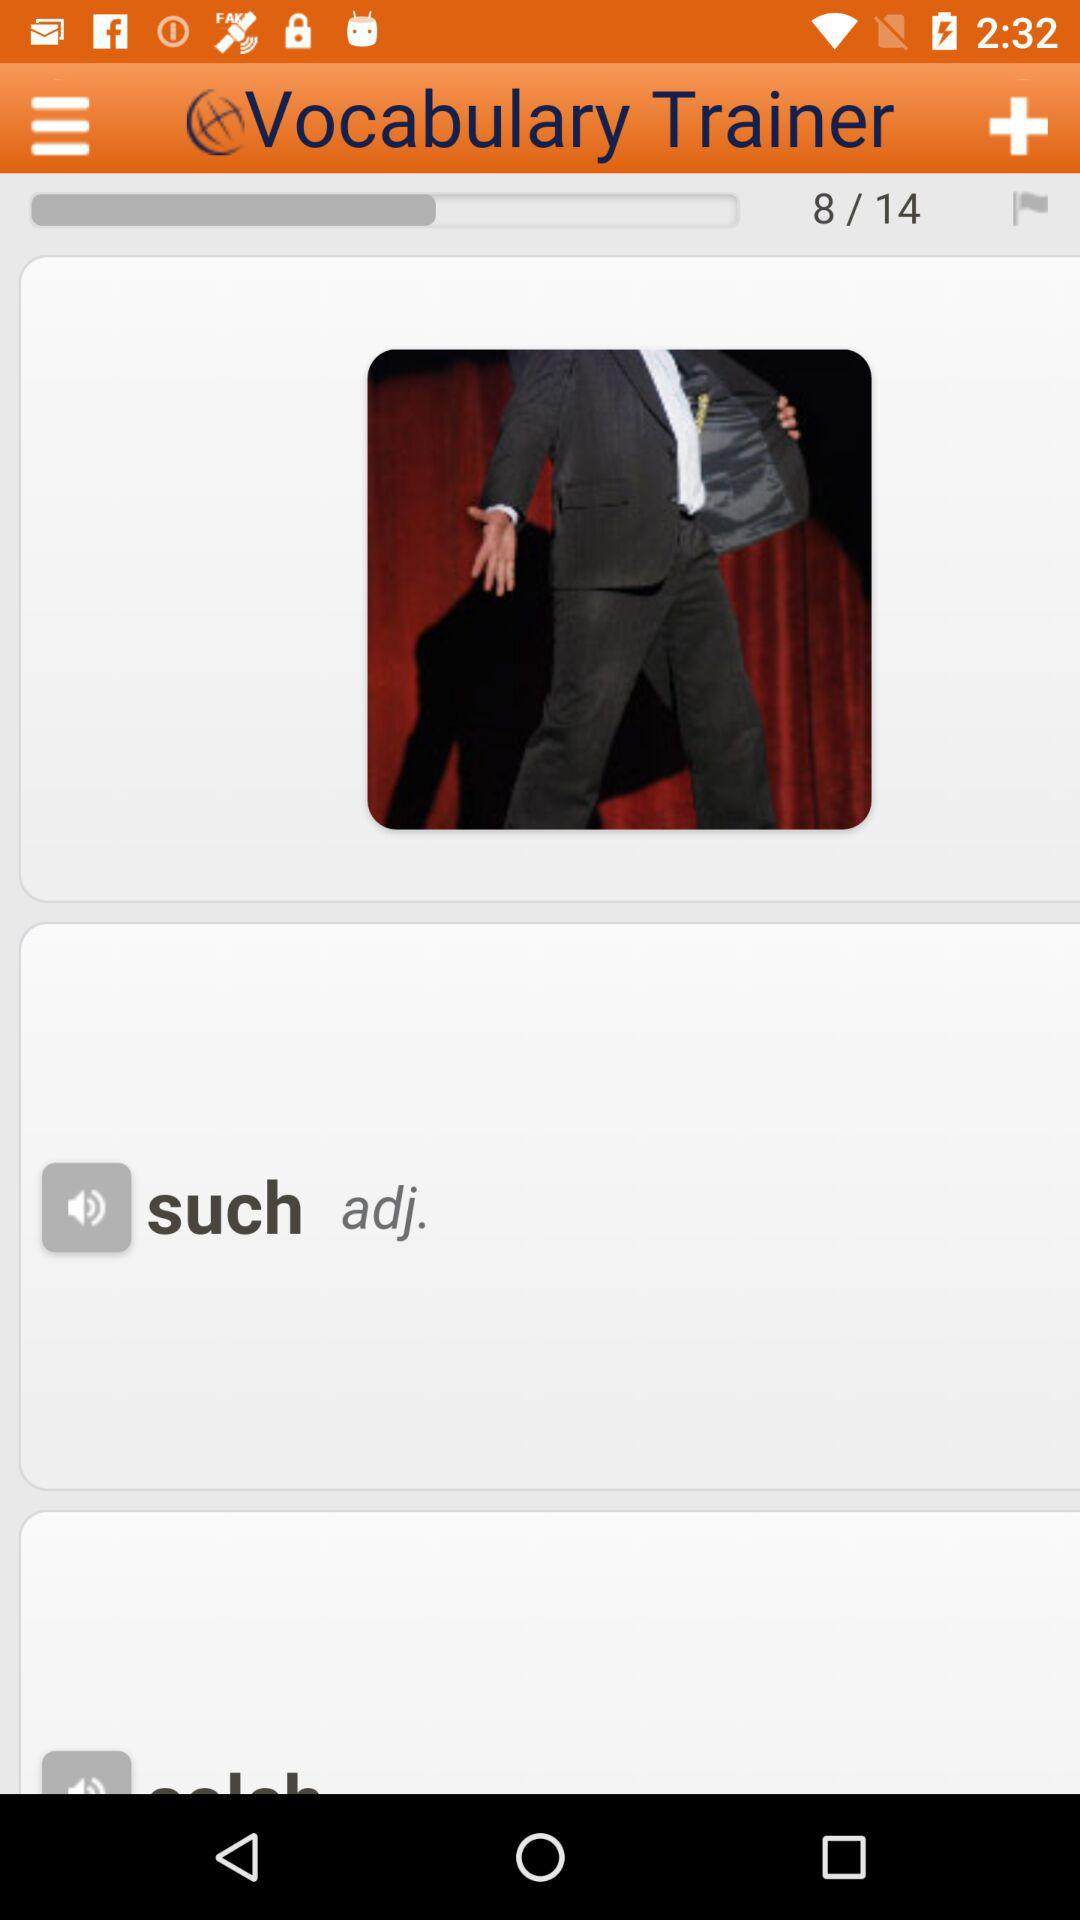What is the name of the application? The name of the application is "Vocabulary Trainer". 